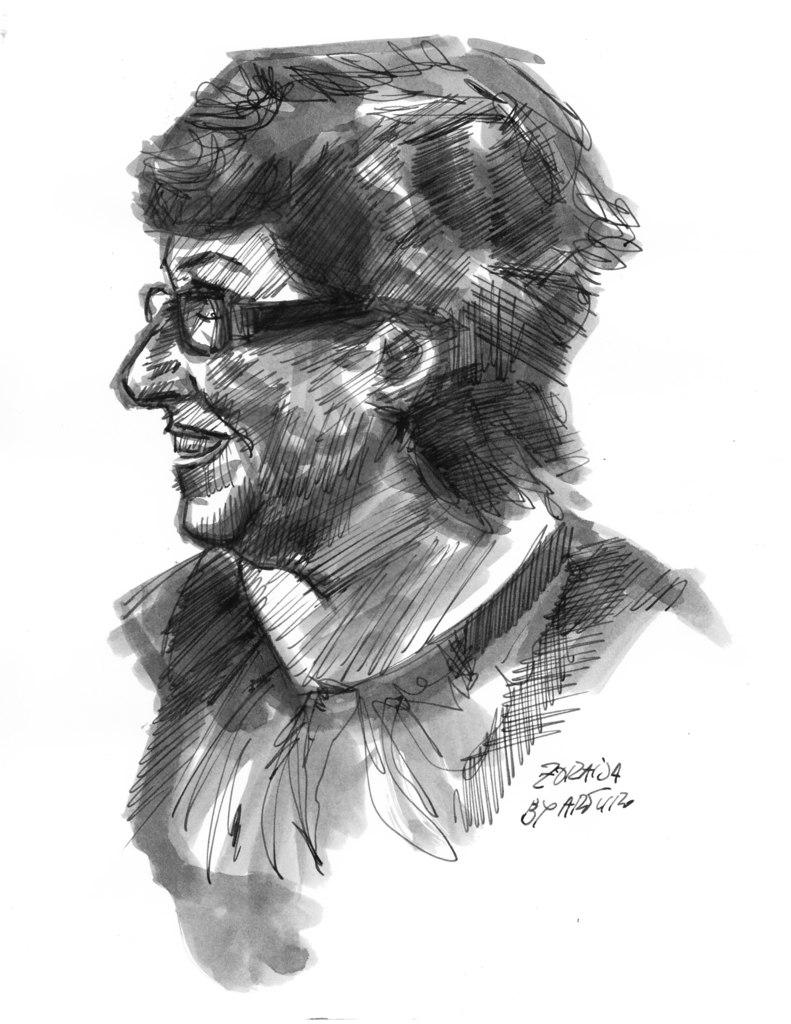What is depicted in the image? There is a sketch of a person in the image. What accessory is the person in the sketch wearing? The person in the sketch is wearing glasses. What else is featured in the image besides the sketch? There is text present in the image. What color is the shirt worn by the person in the sketch? There is no shirt mentioned or visible in the sketch; the person is wearing glasses. What type of light source is illuminating the sketch in the image? There is no specific light source mentioned or visible in the image; it is a sketch on a surface. 